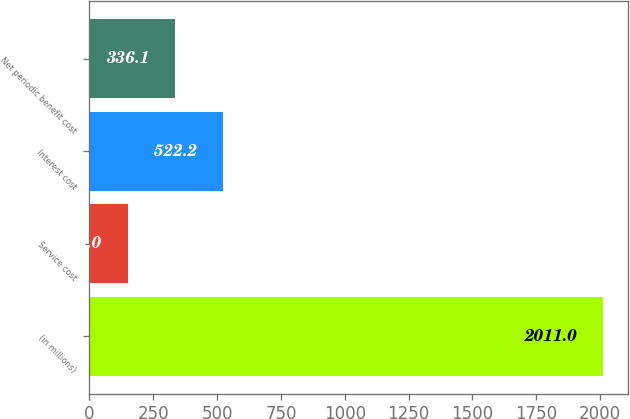Convert chart to OTSL. <chart><loc_0><loc_0><loc_500><loc_500><bar_chart><fcel>(in millions)<fcel>Service cost<fcel>Interest cost<fcel>Net periodic benefit cost<nl><fcel>2011<fcel>150<fcel>522.2<fcel>336.1<nl></chart> 